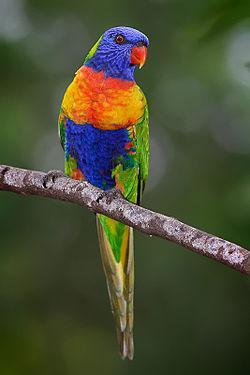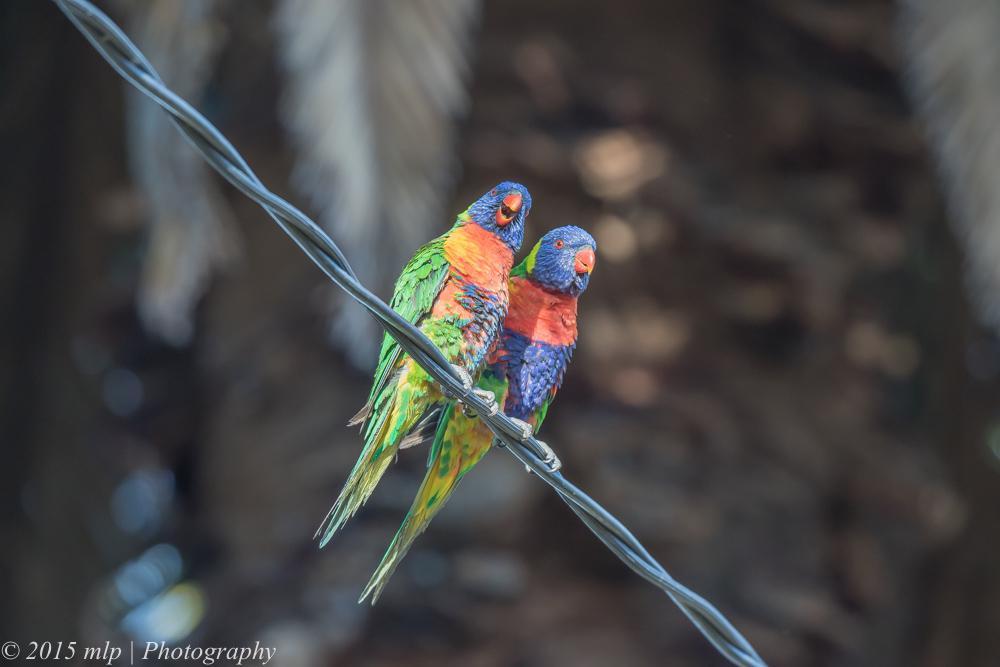The first image is the image on the left, the second image is the image on the right. For the images shown, is this caption "there is exactly one bird in the image on the left" true? Answer yes or no. Yes. The first image is the image on the left, the second image is the image on the right. Assess this claim about the two images: "There are at most 4 birds shown.". Correct or not? Answer yes or no. Yes. 